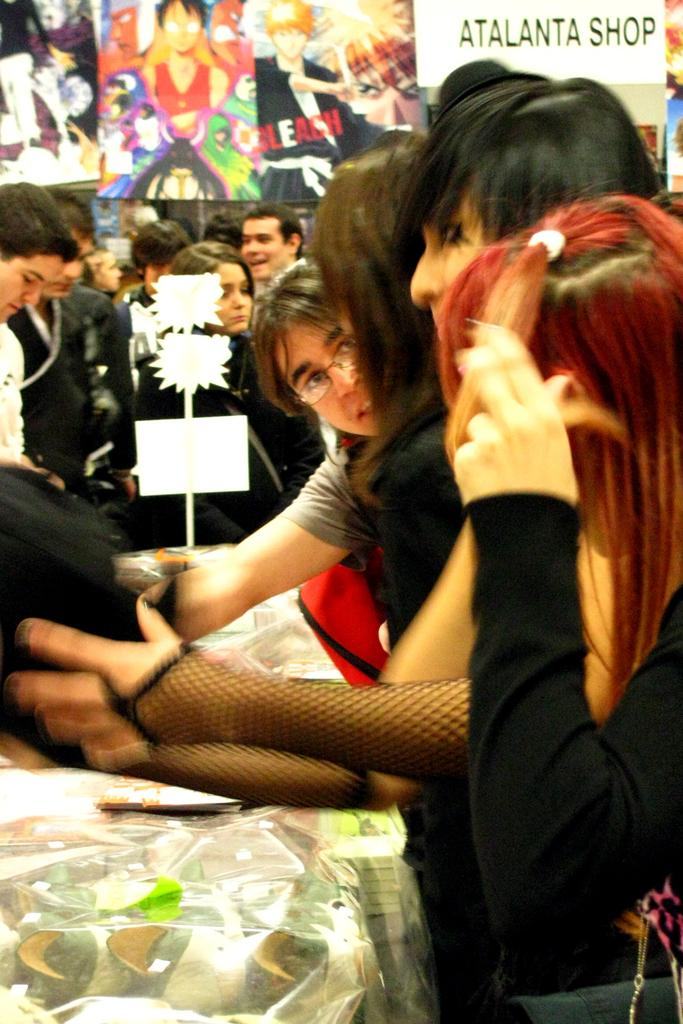What can be seen in the image? There are people standing in the image. What is visible in the background of the image? There are posters in the background of the image. What object is visible in the image? There is a board visible in the image. What type of celery is being used as an example in the image? There is no celery present in the image, so it cannot be used as an example. 